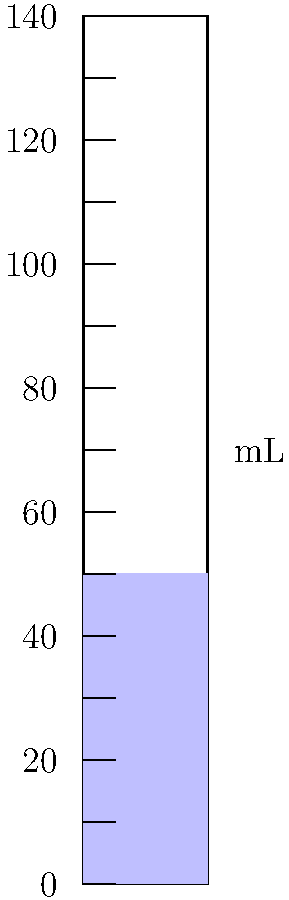As an aspiring pub chef experimenting with new recipes, you need to measure liquid ingredients accurately. The graduated cylinder shown contains a blue liquid. What is the volume of the liquid in milliliters (mL)? To determine the volume of the liquid in the graduated cylinder, we need to follow these steps:

1. Observe the graduated cylinder:
   - The cylinder is marked with graduations every 20 mL.
   - Smaller marks between the labeled graduations represent 10 mL increments.

2. Locate the liquid level:
   - The blue liquid reaches exactly halfway between the 40 mL and 60 mL marks.

3. Calculate the volume:
   - The liquid is above the 40 mL mark.
   - It reaches halfway to the next major graduation (60 mL).
   - The difference between 60 mL and 40 mL is 20 mL.
   - Half of 20 mL is 10 mL.

4. Determine the final volume:
   - $40 \text{ mL} + 10 \text{ mL} = 50 \text{ mL}$

Therefore, the volume of the blue liquid in the graduated cylinder is 50 mL.
Answer: 50 mL 